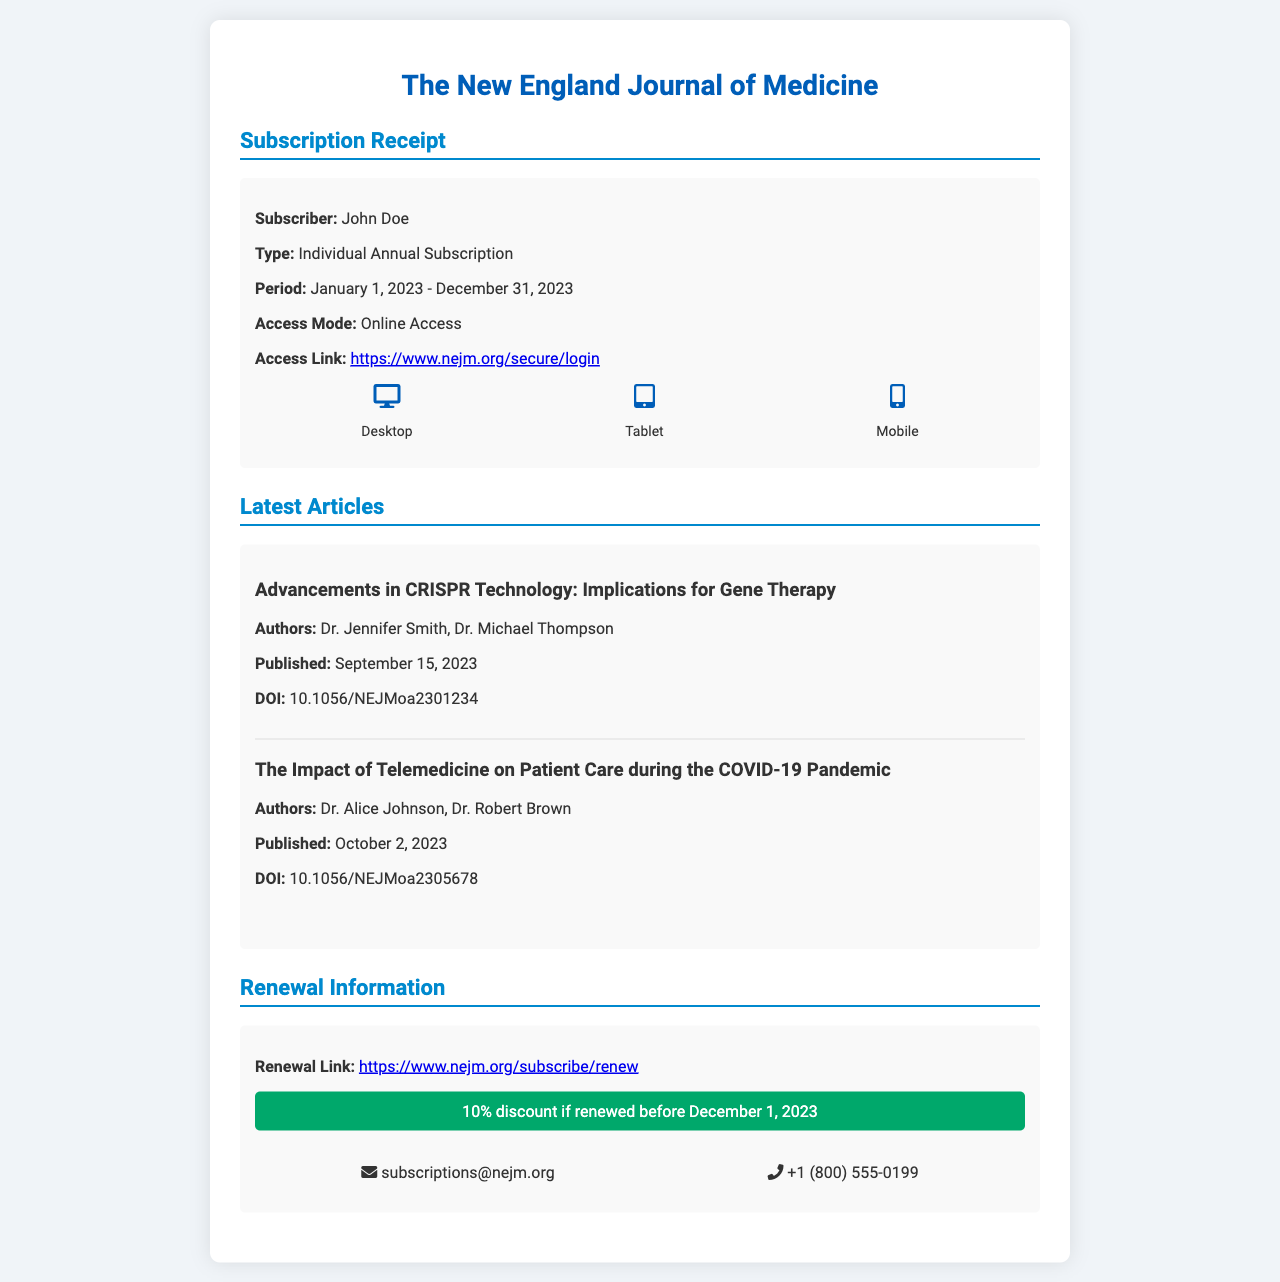What is the subscriber's name? The subscriber's name is explicitly mentioned in the document as "John Doe."
Answer: John Doe What is the subscription type? The subscription type is specified in the document as "Individual Annual Subscription."
Answer: Individual Annual Subscription What is the subscription period? The subscription period is clearly stated in the document from January 1, 2023, to December 31, 2023.
Answer: January 1, 2023 - December 31, 2023 Which article was published on October 2, 2023? The article published on that date is mentioned in the document about telemedicine during the COVID-19 pandemic.
Answer: The Impact of Telemedicine on Patient Care during the COVID-19 Pandemic What is the DOI of the first article? The document provides the DOI for the first article as 10.1056/NEJMoa2301234.
Answer: 10.1056/NEJMoa2301234 What discount is available for early renewal? The document offers a specific percentage discount for early renewal before December 1, 2023.
Answer: 10% What is the access mode for the subscription? The access mode is explicitly listed in the document, highlighting how the subscriber can access the journal.
Answer: Online Access How can subscribers renew their subscription? The method for renewal is indicated in the document through a specific link for renewal.
Answer: Renew through the renewal link What is the contact email for subscriptions? The document states the contact email explicitly for any subscription inquiries.
Answer: subscriptions@nejm.org 